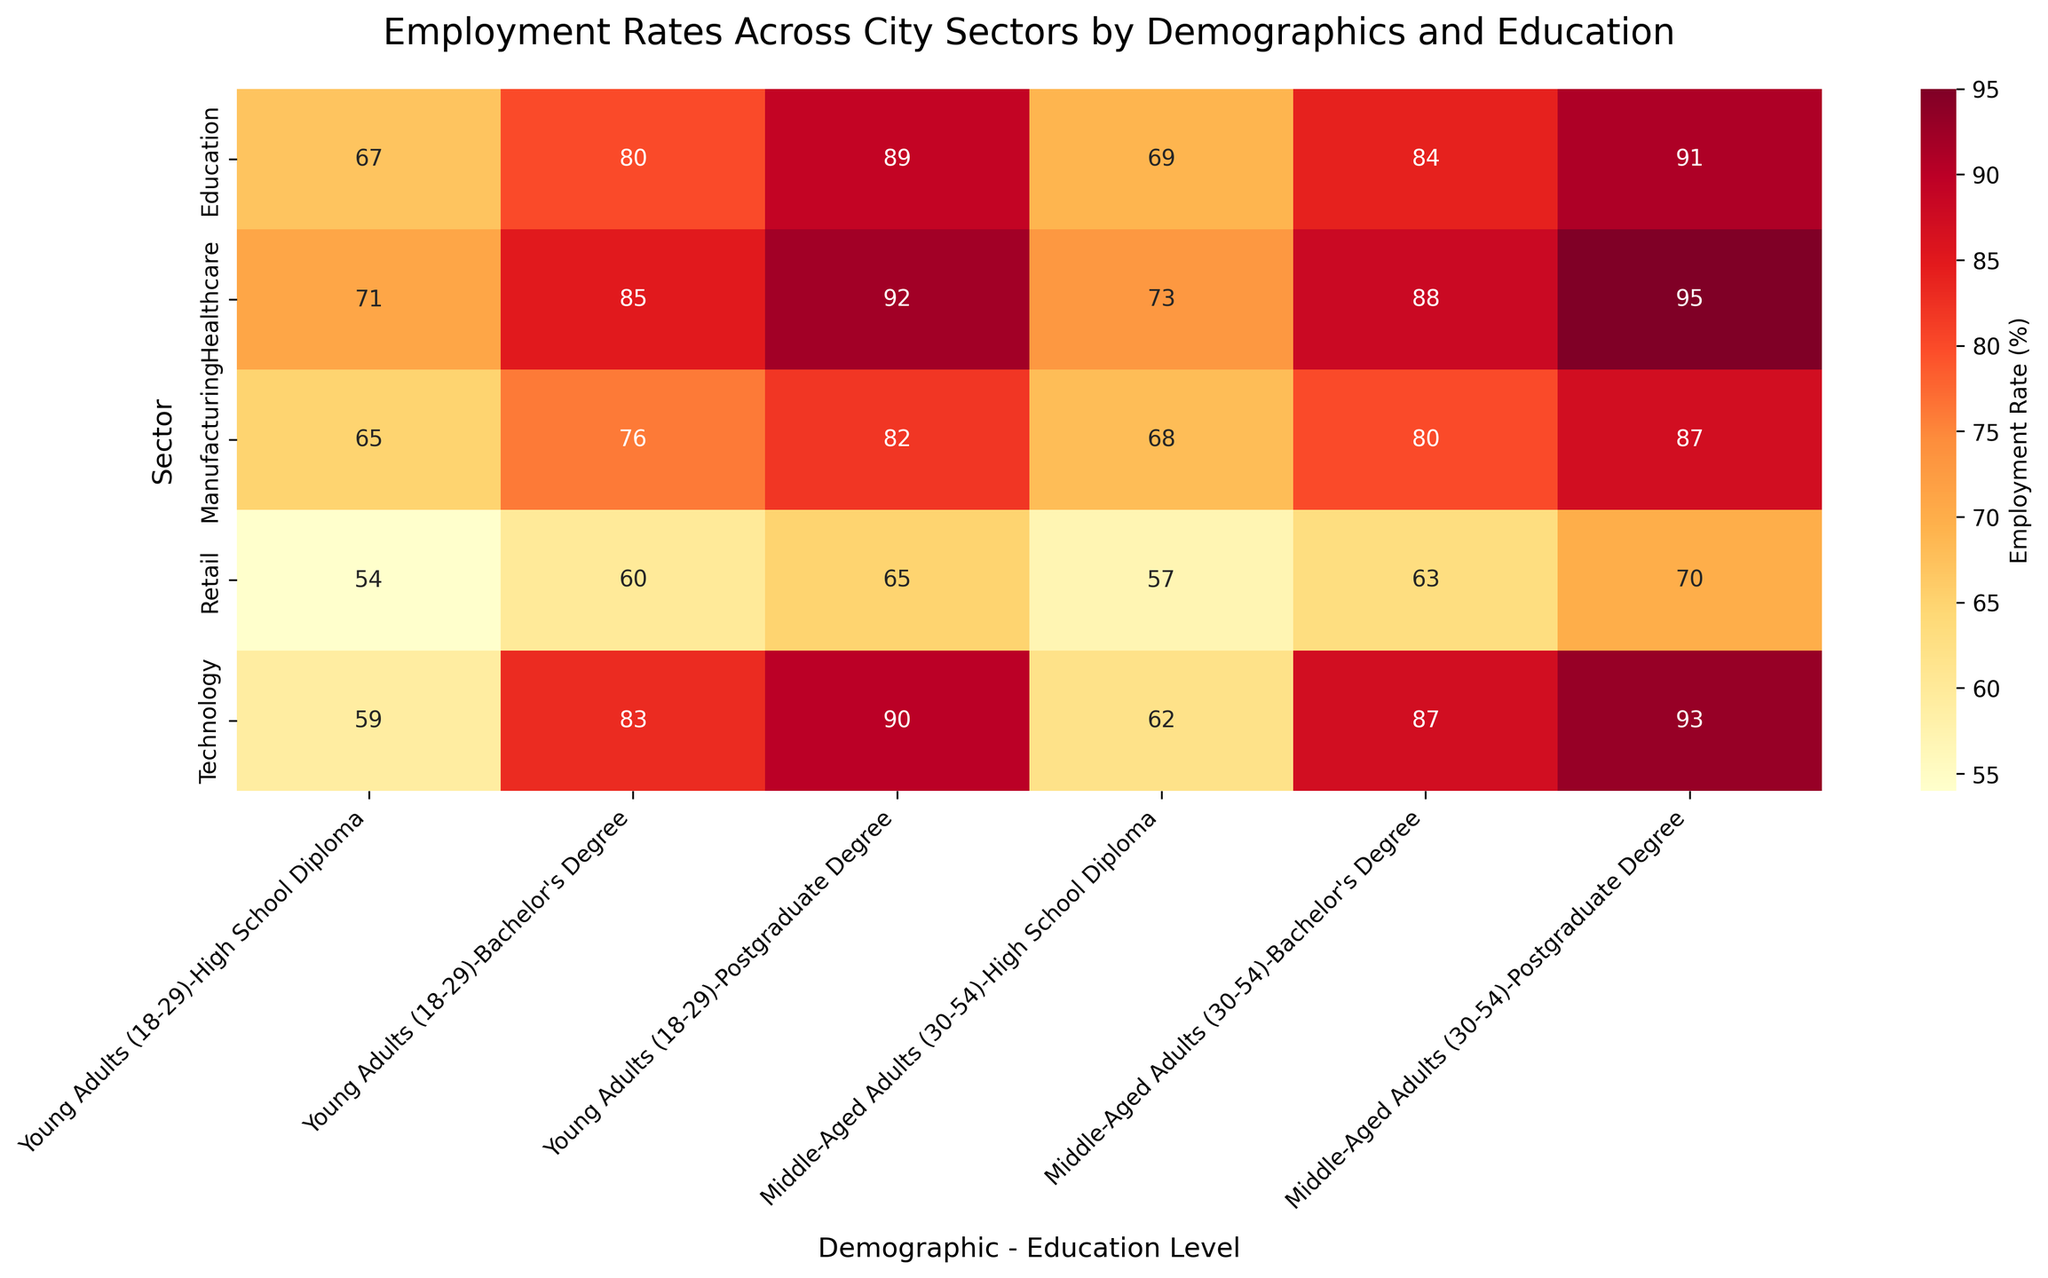What's the title of the figure? The title is written at the top of the figure. It provides a summary of what the heatmap represents.
Answer: Employment Rates Across City Sectors by Demographics and Education Which sector has the highest employment rate for young adults with a bachelor's degree? Look for the highest number in the column corresponding to 'Young Adults (18-29)' and 'Bachelor's Degree' across different sectors.
Answer: Healthcare What is the employment rate difference between young adults and middle-aged adults with high school diplomas in the manufacturing sector? Find the employment rates for both groups in the Manufacturing sector and calculate the difference: 68 (Middle-Aged) - 65 (Young Adults) = 3.
Answer: 3% Which sector has the lowest employment rate for any demographic-education level combination? Identify the smallest number on the heatmap which represents the employment rate, along with its corresponding sector.
Answer: Retail How does the employment rate in the education sector for middle-aged adults with postgraduate degrees compare to young adults with the same level of education? Compare the two employment rates in the Education sector: Middle-Aged Adults (91) and Young Adults (89).
Answer: Higher by 2% What’s the average employment rate for middle-aged adults with bachelor’s degrees across all sectors? Calculate the average of the employment rates for middle-aged adults with bachelor's degrees in Healthcare (88), Technology (87), Education (84), Manufacturing (80), and Retail (63): (88+87+84+80+63)/5.
Answer: 80.4% Is the employment rate for middle-aged adults with high school diplomas usually higher or lower than for young adults with the same education level? Compare the employment rates for middle-aged adults and young adults with high school diplomas across all sectors. Generally, middle-aged adults have higher or comparable rates to young adults.
Answer: Higher In which sector is the employment rate more sensitive to education level changes? Look for the sector with the largest differences in employment rates among different education levels for the same demographic.
Answer: Technology Between the healthcare and technology sectors, which one has a more balanced employment rate across different education levels for young adults? Compare the employment rates for young adults across all education levels in both sectors. The Healthcare sector has more uniform rates (71, 85, 92) than the Technology sector (59, 83, 90).
Answer: Healthcare 